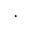<formula> <loc_0><loc_0><loc_500><loc_500>.</formula> 